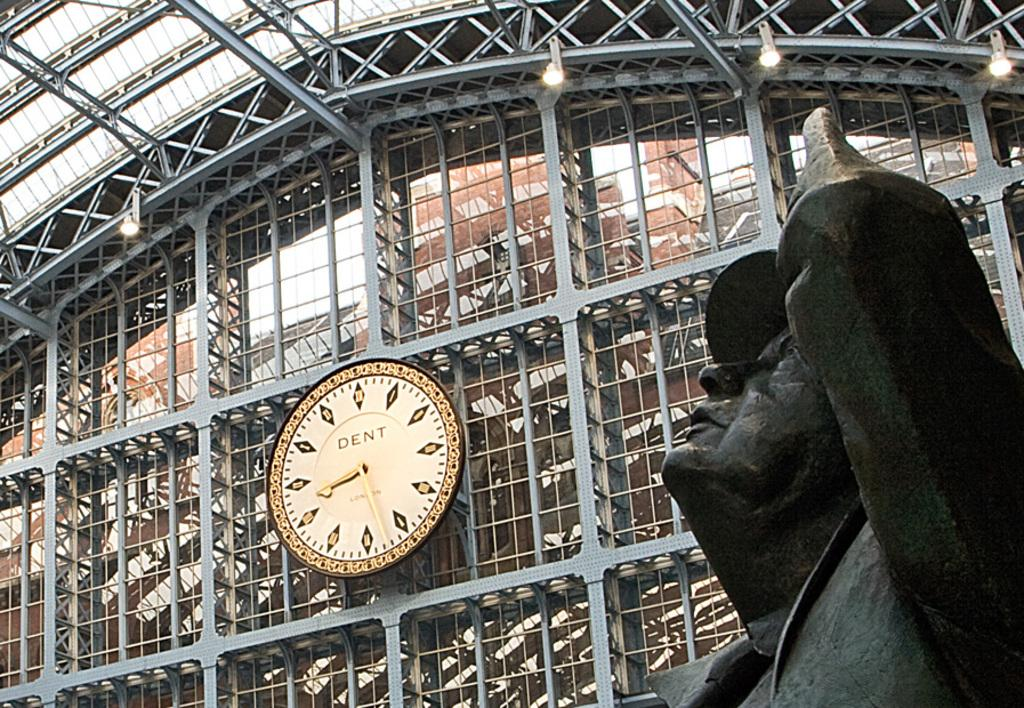Provide a one-sentence caption for the provided image. The Dent clock is visible above the statue. 